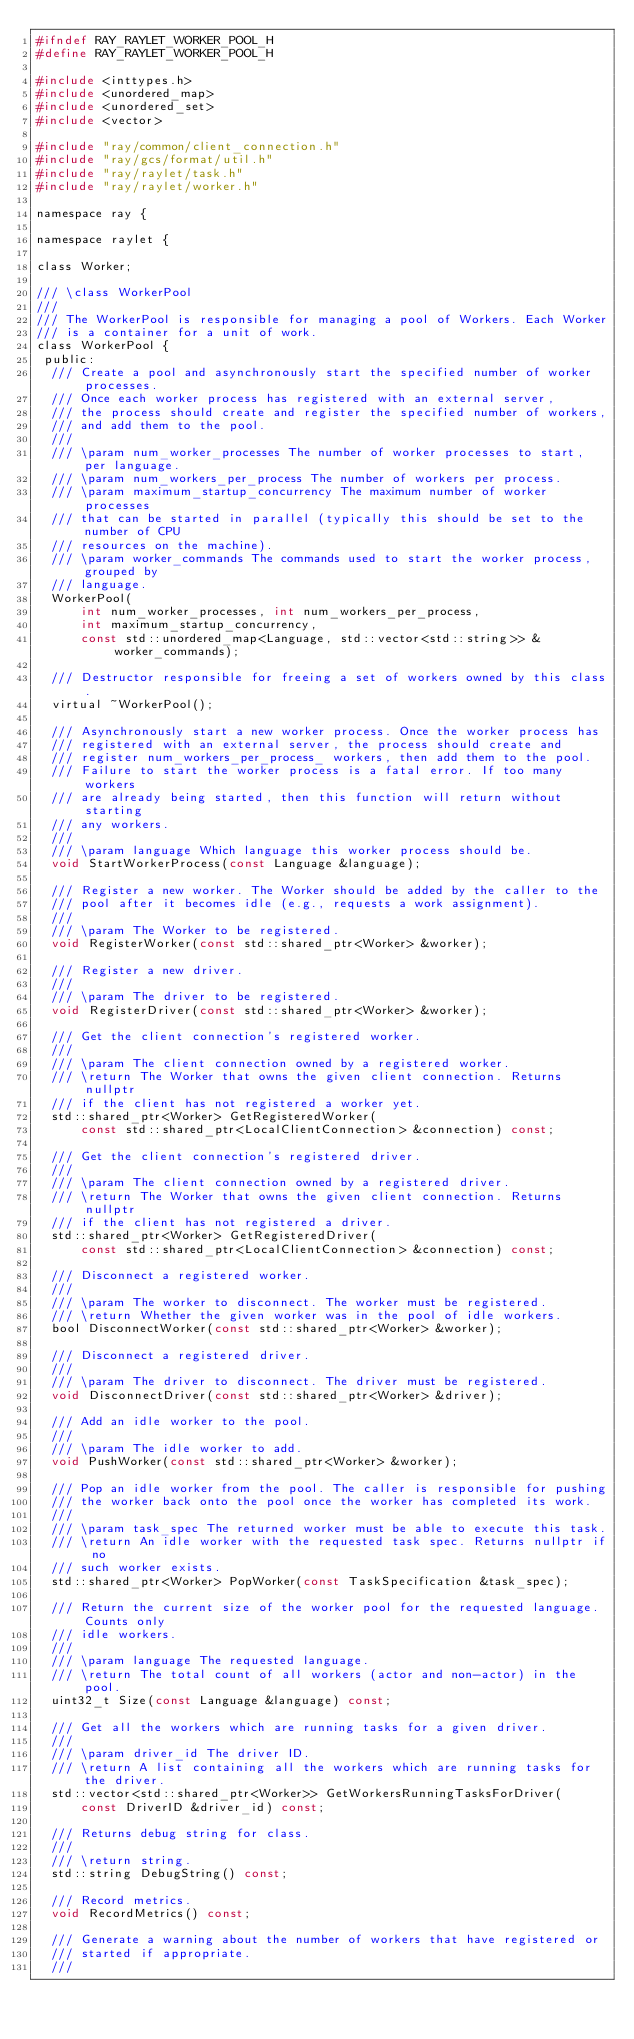Convert code to text. <code><loc_0><loc_0><loc_500><loc_500><_C_>#ifndef RAY_RAYLET_WORKER_POOL_H
#define RAY_RAYLET_WORKER_POOL_H

#include <inttypes.h>
#include <unordered_map>
#include <unordered_set>
#include <vector>

#include "ray/common/client_connection.h"
#include "ray/gcs/format/util.h"
#include "ray/raylet/task.h"
#include "ray/raylet/worker.h"

namespace ray {

namespace raylet {

class Worker;

/// \class WorkerPool
///
/// The WorkerPool is responsible for managing a pool of Workers. Each Worker
/// is a container for a unit of work.
class WorkerPool {
 public:
  /// Create a pool and asynchronously start the specified number of worker processes.
  /// Once each worker process has registered with an external server,
  /// the process should create and register the specified number of workers,
  /// and add them to the pool.
  ///
  /// \param num_worker_processes The number of worker processes to start, per language.
  /// \param num_workers_per_process The number of workers per process.
  /// \param maximum_startup_concurrency The maximum number of worker processes
  /// that can be started in parallel (typically this should be set to the number of CPU
  /// resources on the machine).
  /// \param worker_commands The commands used to start the worker process, grouped by
  /// language.
  WorkerPool(
      int num_worker_processes, int num_workers_per_process,
      int maximum_startup_concurrency,
      const std::unordered_map<Language, std::vector<std::string>> &worker_commands);

  /// Destructor responsible for freeing a set of workers owned by this class.
  virtual ~WorkerPool();

  /// Asynchronously start a new worker process. Once the worker process has
  /// registered with an external server, the process should create and
  /// register num_workers_per_process_ workers, then add them to the pool.
  /// Failure to start the worker process is a fatal error. If too many workers
  /// are already being started, then this function will return without starting
  /// any workers.
  ///
  /// \param language Which language this worker process should be.
  void StartWorkerProcess(const Language &language);

  /// Register a new worker. The Worker should be added by the caller to the
  /// pool after it becomes idle (e.g., requests a work assignment).
  ///
  /// \param The Worker to be registered.
  void RegisterWorker(const std::shared_ptr<Worker> &worker);

  /// Register a new driver.
  ///
  /// \param The driver to be registered.
  void RegisterDriver(const std::shared_ptr<Worker> &worker);

  /// Get the client connection's registered worker.
  ///
  /// \param The client connection owned by a registered worker.
  /// \return The Worker that owns the given client connection. Returns nullptr
  /// if the client has not registered a worker yet.
  std::shared_ptr<Worker> GetRegisteredWorker(
      const std::shared_ptr<LocalClientConnection> &connection) const;

  /// Get the client connection's registered driver.
  ///
  /// \param The client connection owned by a registered driver.
  /// \return The Worker that owns the given client connection. Returns nullptr
  /// if the client has not registered a driver.
  std::shared_ptr<Worker> GetRegisteredDriver(
      const std::shared_ptr<LocalClientConnection> &connection) const;

  /// Disconnect a registered worker.
  ///
  /// \param The worker to disconnect. The worker must be registered.
  /// \return Whether the given worker was in the pool of idle workers.
  bool DisconnectWorker(const std::shared_ptr<Worker> &worker);

  /// Disconnect a registered driver.
  ///
  /// \param The driver to disconnect. The driver must be registered.
  void DisconnectDriver(const std::shared_ptr<Worker> &driver);

  /// Add an idle worker to the pool.
  ///
  /// \param The idle worker to add.
  void PushWorker(const std::shared_ptr<Worker> &worker);

  /// Pop an idle worker from the pool. The caller is responsible for pushing
  /// the worker back onto the pool once the worker has completed its work.
  ///
  /// \param task_spec The returned worker must be able to execute this task.
  /// \return An idle worker with the requested task spec. Returns nullptr if no
  /// such worker exists.
  std::shared_ptr<Worker> PopWorker(const TaskSpecification &task_spec);

  /// Return the current size of the worker pool for the requested language. Counts only
  /// idle workers.
  ///
  /// \param language The requested language.
  /// \return The total count of all workers (actor and non-actor) in the pool.
  uint32_t Size(const Language &language) const;

  /// Get all the workers which are running tasks for a given driver.
  ///
  /// \param driver_id The driver ID.
  /// \return A list containing all the workers which are running tasks for the driver.
  std::vector<std::shared_ptr<Worker>> GetWorkersRunningTasksForDriver(
      const DriverID &driver_id) const;

  /// Returns debug string for class.
  ///
  /// \return string.
  std::string DebugString() const;

  /// Record metrics.
  void RecordMetrics() const;

  /// Generate a warning about the number of workers that have registered or
  /// started if appropriate.
  ///</code> 